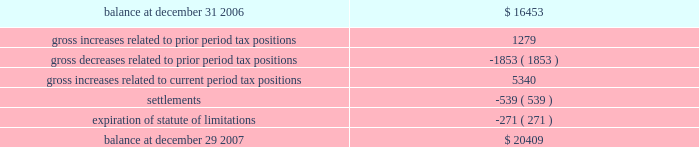Advance auto parts , inc .
And subsidiaries notes to the consolidated financial statements 2013 ( continued ) december 29 , 2007 , december 30 , 2006 and december 31 , 2005 ( in thousands , except per share data ) 11 .
Stock repurchase program : during fiscal 2007 , the company's board of directors authorized a new stock repurchase program of up to $ 500000 of the company's common stock plus related expenses .
The new program cancelled and replaced the remaining portion of the previous $ 300000 stock repurchase program .
The program allows the company to repurchase its common stock on the open market or in privately negotiated transactions from time to time in accordance with the requirements of the securities and exchange commission .
During fiscal 2007 , the company repurchased 8341 shares of common stock at an aggregate cost of $ 285869 , or an average price of $ 34.27 per share , of which 1330 shares of common stock were repurchased under the previous $ 300000 stock repurchase program .
As of december 29 , 2007 , 77 shares have been repurchased at an aggregate cost of $ 2959 and remained unsettled .
During fiscal 2007 , the company retired 6329 shares previously repurchased under the stock repurchase programs .
At december 29 , 2007 , the company had $ 260567 remaining under the current stock repurchase program .
Subsequent to december 29 , 2007 , the company repurchased 4563 shares of common stock at an aggregate cost of $ 155350 , or an average price of $ 34.04 per share .
During fiscal 2006 , the company retired 5117 shares of common stock which were previously repurchased under the company 2019s prior stock repurchase program .
These shares were repurchased during fiscal 2006 and fiscal 2005 at an aggregate cost of $ 192339 , or an average price of $ 37.59 per share .
12 .
Income taxes : as a result of the adoption of fin 48 on december 31 , 2006 , the company recorded an increase of $ 2275 to the liability for unrecognized tax benefits and a corresponding decrease in its balance of retained earnings .
The table summarizes the activity related to our unrecognized tax benefits for the fiscal year ended december 29 , 2007: .
As of december 29 , 2007 the entire amount of unrecognized tax benefits , if recognized , would reduce the company 2019s annual effective tax rate .
With the adoption of fin 48 , the company provides for interest and penalties as a part of income tax expense .
During fiscal 2007 , the company accrued potential penalties and interest of $ 709 and $ 1827 , respectively , related to these unrecognized tax benefits .
As of december 29 , 2007 , the company has recorded a liability for potential penalties and interest of $ 1843 and $ 4421 , respectively .
Prior to the adoption of fin 48 , the company classified interest associated with tax contingencies in interest expense .
The company has not provided for any penalties associated with tax contingencies unless considered probable of assessment .
The company does not expect its unrecognized tax benefits to change significantly over the next 12 months .
During the next 12 months , it is possible the company could conclude on $ 2000 to $ 3000 of the contingencies associated with unrecognized tax uncertainties due mainly to settlements and expiration of statute of limitations ( including tax benefits , interest and penalties ) .
The majority of these resolutions would be achieved through the completion of current income tax examinations. .
What is the net change in the balance unrecognized tax benefits in 2007? 
Computations: (20409 - 16453)
Answer: 3956.0. 